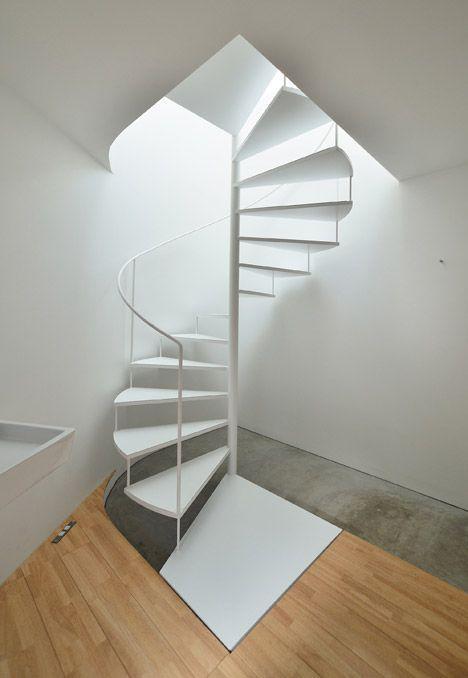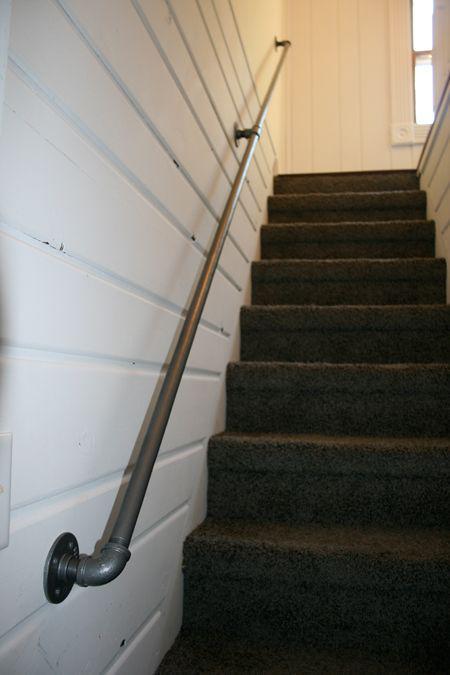The first image is the image on the left, the second image is the image on the right. Examine the images to the left and right. Is the description "The stairway in the image on the right is bordered with glass panels." accurate? Answer yes or no. No. The first image is the image on the left, the second image is the image on the right. Assess this claim about the two images: "An image shows an upward view of an uncurved ascending staircase with glass panels on one side.". Correct or not? Answer yes or no. No. 